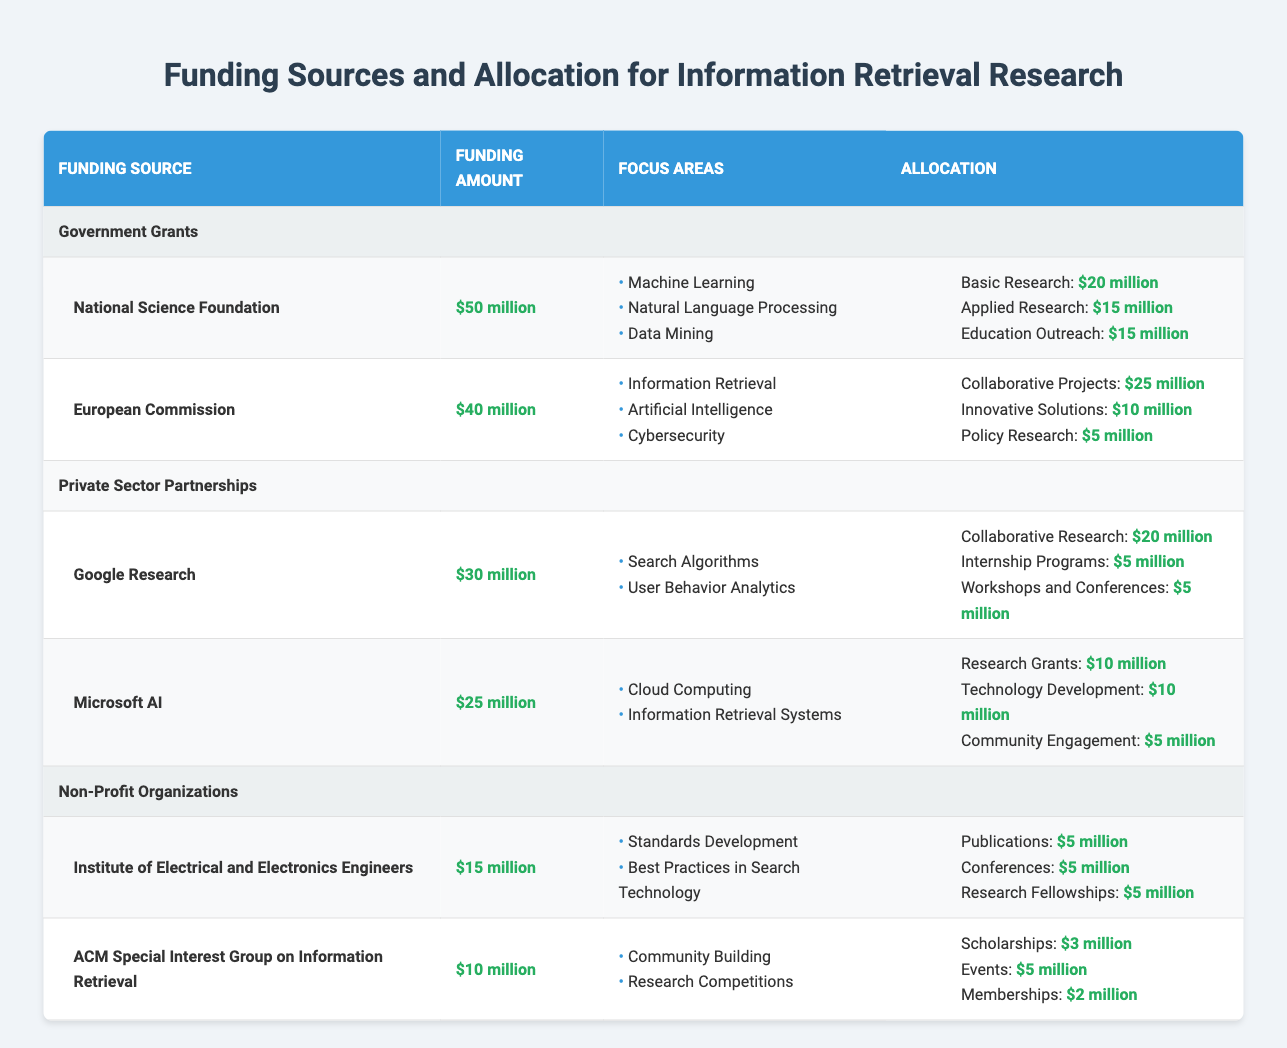What is the total funding amount from Government Grants? The total funding amount from Government Grants can be calculated by adding the funding amounts for each source under Government Grants: National Science Foundation ($50 million) + European Commission ($40 million) = $90 million.
Answer: $90 million Which organization has the highest single funding amount? By examining the funding amounts, the National Science Foundation has the highest single funding amount at $50 million, compared to all other organizations listed.
Answer: National Science Foundation Is there any funding allocated specifically for Educational Outreach? Yes, the National Science Foundation has allocated $15 million specifically for Education Outreach. This information is directly listed in the allocation details under their respective funding source.
Answer: Yes What is the total funding allocated for Community Engagement across all sources? To find the total funding for Community Engagement, we look at its allocation under each organization. Microsoft AI has $5 million allocated for Community Engagement. Other organizations do not mention this allocation. Therefore, the total is $5 million.
Answer: $5 million What percentage of Google Research's funding amount is allocated for Collaborative Research? To find this percentage, first, note that Google Research's total funding amount is $30 million, with $20 million allocated for Collaborative Research. The calculation for the percentage is (20 million / 30 million) * 100 = 66.67%.
Answer: 66.67% 